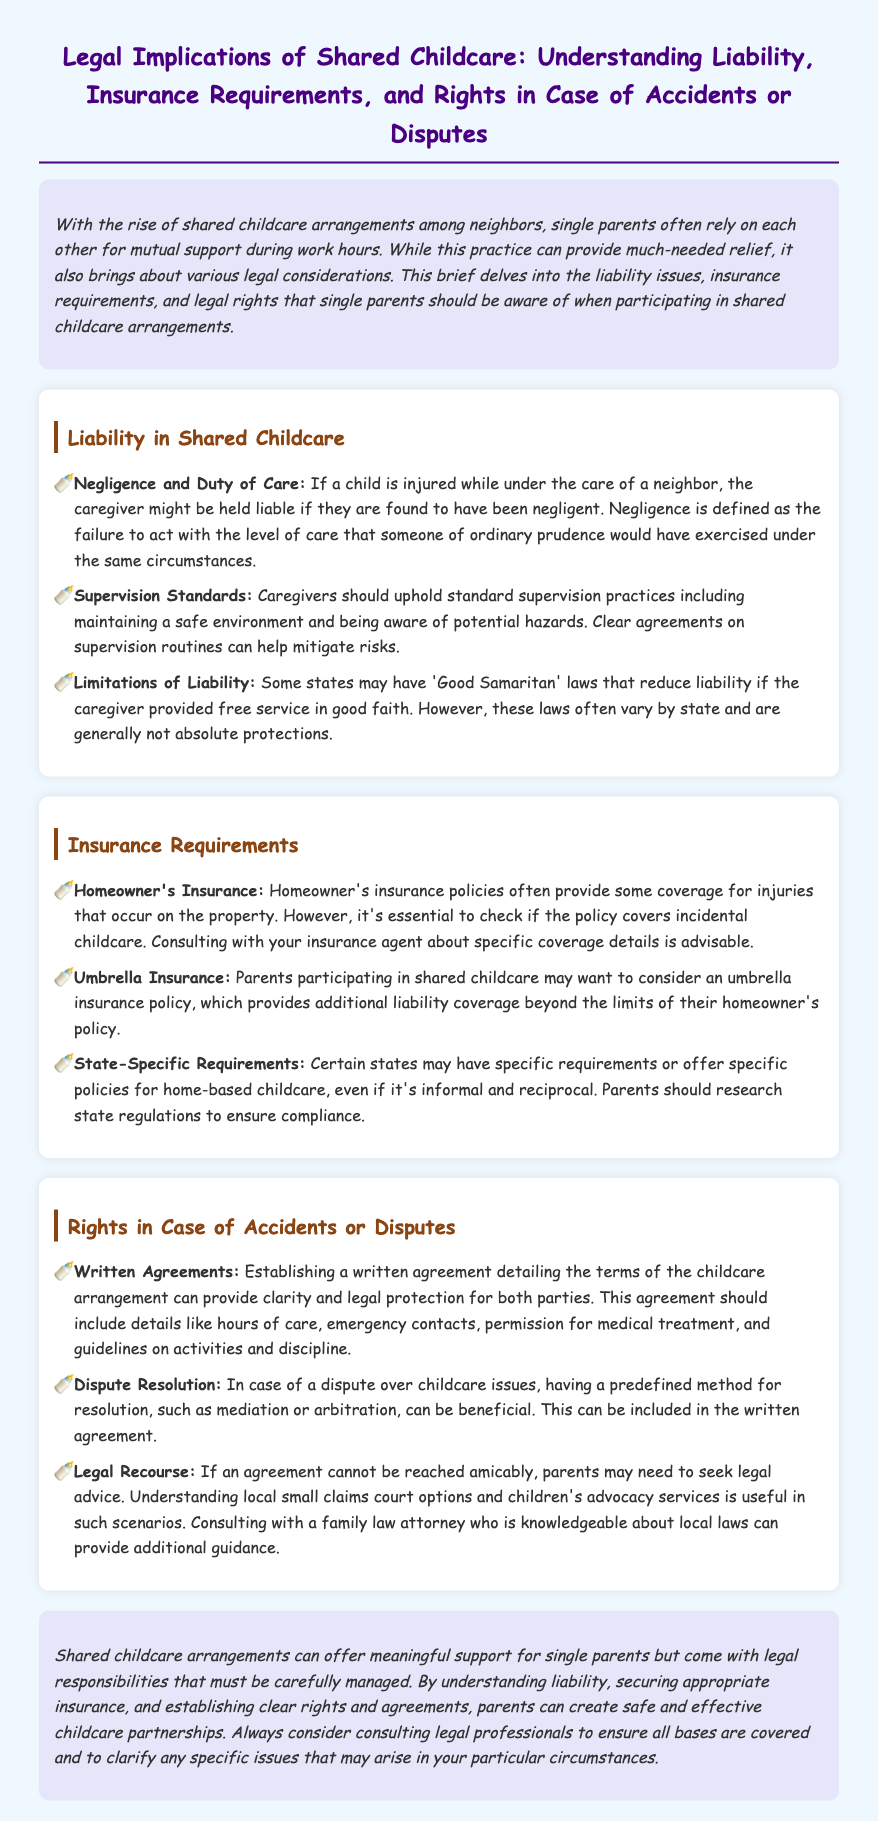What is the primary focus of the document? The primary focus of the document is on the legal implications surrounding shared childcare arrangements among single parents, particularly regarding liability, insurance, and rights in cases of accidents or disputes.
Answer: Legal implications of shared childcare What does negligence refer to in the context of shared childcare? Negligence refers to the failure to act with the level of care that someone of ordinary prudence would have exercised under the same circumstances.
Answer: Failure to act with ordinary prudence What type of insurance may parents want to consider? Parents may want to consider an umbrella insurance policy, which provides additional liability coverage beyond the limits of their homeowner's policy.
Answer: Umbrella insurance What should a written agreement include? A written agreement should include details such as hours of care, emergency contacts, permission for medical treatment, and guidelines on activities and discipline.
Answer: Hours of care, emergency contacts, permission for medical treatment, guidelines on activities and discipline Which laws may reduce liability for caregivers? Some states may have 'Good Samaritan' laws that can reduce liability for caregivers who provided free service in good faith.
Answer: Good Samaritan laws What is advised when it comes to homeowner's insurance policies? It is essential to check if the homeowner's insurance policy covers incidental childcare.
Answer: Check for coverage of incidental childcare 